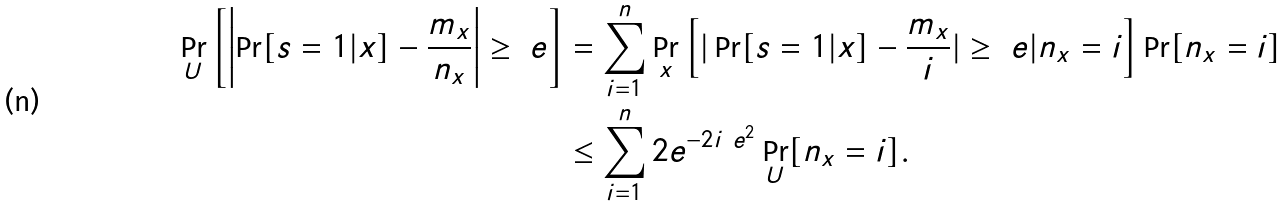Convert formula to latex. <formula><loc_0><loc_0><loc_500><loc_500>\Pr _ { U } \left [ \left | \Pr [ s = 1 | x ] - \frac { m _ { x } } { n _ { x } } \right | \geq \ e \right ] & = \sum _ { i = 1 } ^ { n } \Pr _ { x } \left [ | \Pr [ s = 1 | x ] - \frac { m _ { x } } { i } | \geq \ e | n _ { x } = i \right ] \Pr [ n _ { x } = i ] \\ & \leq \sum _ { i = 1 } ^ { n } 2 e ^ { - 2 i \ e ^ { 2 } } \Pr _ { U } [ n _ { x } = i ] .</formula> 